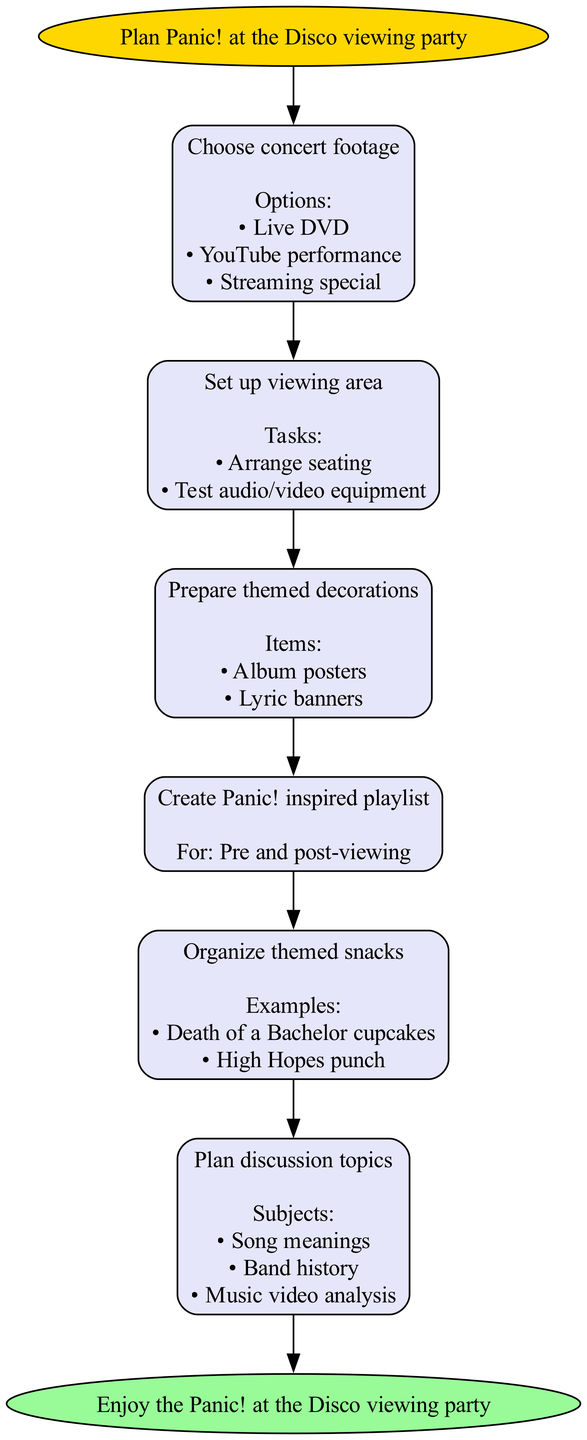What is the first step in planning a Panic! at the Disco viewing party? The first step is indicated at the start of the diagram, which states "Choose concert footage." This is the first node following the initial start node.
Answer: Choose concert footage How many steps are in the viewing party plan? The diagram contains a list of six steps, each represented by a separate node between the start and end nodes.
Answer: Six What are the options for choosing concert footage? The "Choose concert footage" node includes a list of options, namely "Live DVD," "YouTube performance," and "Streaming special." These can be found directly under that node.
Answer: Live DVD, YouTube performance, Streaming special What is the purpose of the "Prepare themed decorations" step? This step is focused on enhancing the viewing experience by making the environment more appealing, as indicated by the items listed: "Album posters" and "Lyric banners" that aim to celebrate the band's aesthetic.
Answer: Themed decorations What are some discussion topics to plan for? The "Plan discussion topics" step reflects several subjects underneath it, such as "Song meanings," "Band history," and "Music video analysis." This information shows what can be discussed during the party.
Answer: Song meanings, Band history, Music video analysis What must be arranged in the "Set up viewing area" step? This step specifies two tasks that must be completed: "Arrange seating" and "Test audio/video equipment." Each of these tasks is crucial for creating a comfortable viewing experience.
Answer: Seating, audio/video equipment Which step follows after "Create Panic! inspired playlist"? The flow of the diagram indicates that "Organize themed snacks" is the next step that comes after "Create Panic! inspired playlist." The directional arrows show this sequential order clearly.
Answer: Organize themed snacks What items are suggested for themed snacks? The "Organize themed snacks" step lists examples of items, notably "Death of a Bachelor cupcakes" and "High Hopes punch." These specific examples illustrate the themed snack options that can be prepared.
Answer: Death of a Bachelor cupcakes, High Hopes punch What is the final node in the diagram? The diagram concludes with an end node that states "Enjoy the Panic! at the Disco viewing party," summarizing the end goal of the entire planning process.
Answer: Enjoy the Panic! at the Disco viewing party 